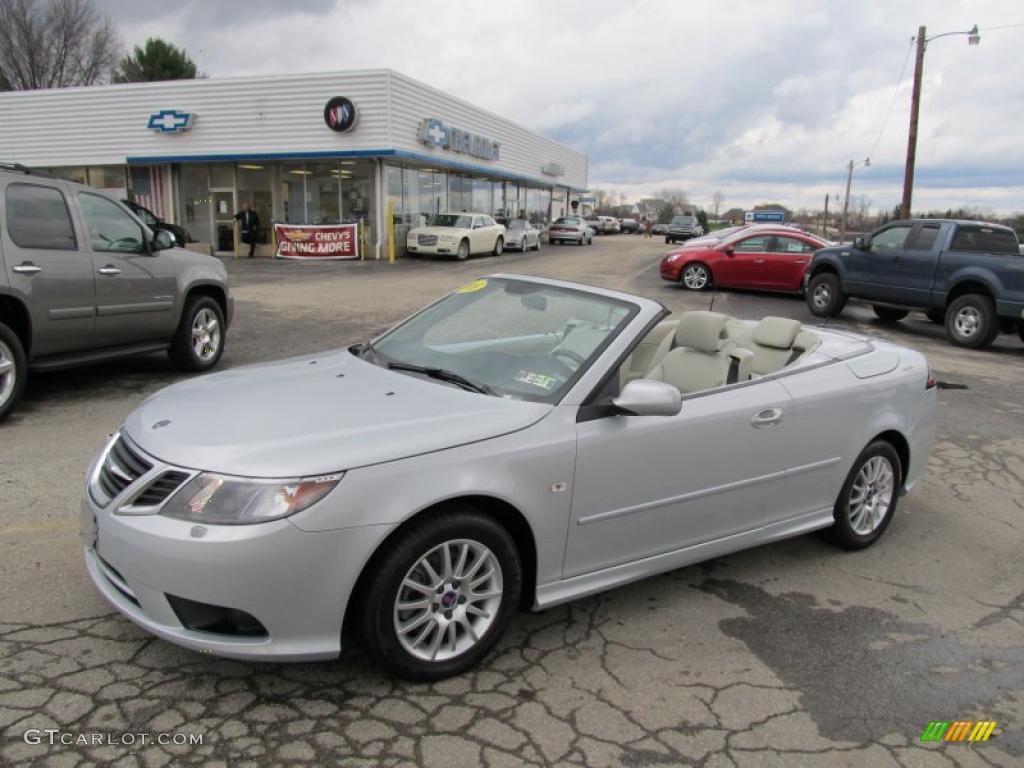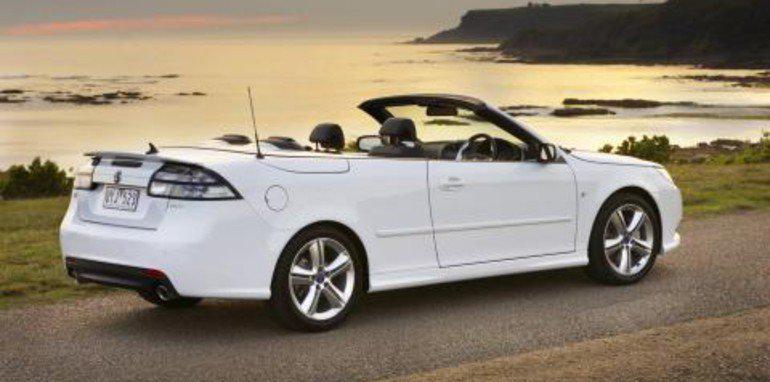The first image is the image on the left, the second image is the image on the right. Given the left and right images, does the statement "Two convertibles with black interior are facing foreward in different directions, both with chrome wheels, but only one with a license plate." hold true? Answer yes or no. No. The first image is the image on the left, the second image is the image on the right. Assess this claim about the two images: "Both left and right images contain a topless convertible facing forward, but only the car on the left has a driver behind the wheel.". Correct or not? Answer yes or no. No. 